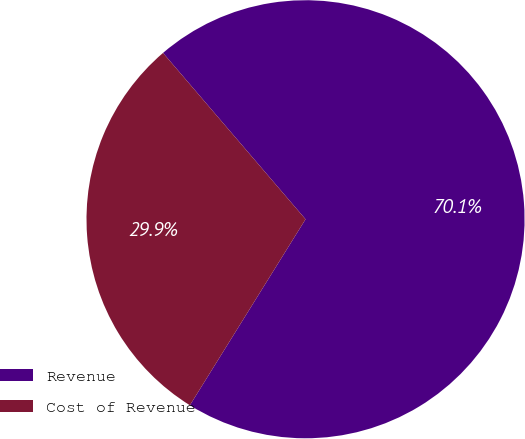Convert chart. <chart><loc_0><loc_0><loc_500><loc_500><pie_chart><fcel>Revenue<fcel>Cost of Revenue<nl><fcel>70.13%<fcel>29.87%<nl></chart> 